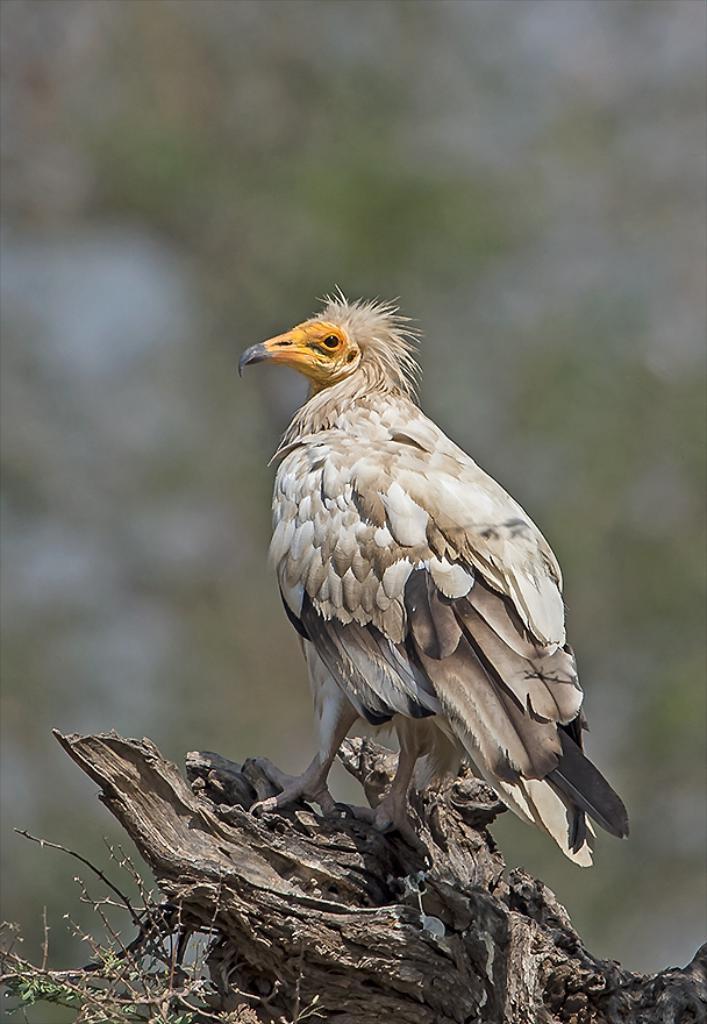Could you give a brief overview of what you see in this image? In the image there is a bird standing on a wooden branch. 